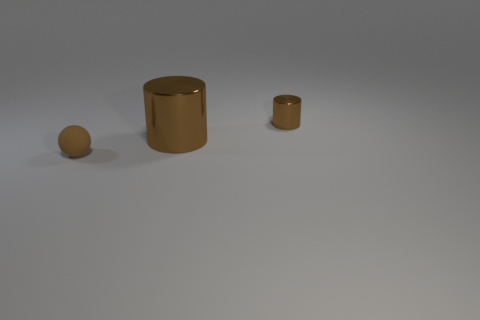Subtract 1 balls. How many balls are left? 0 Add 3 metal objects. How many objects exist? 6 Subtract all spheres. How many objects are left? 2 Subtract all metallic cylinders. Subtract all big brown metallic spheres. How many objects are left? 1 Add 1 balls. How many balls are left? 2 Add 2 spheres. How many spheres exist? 3 Subtract 0 gray balls. How many objects are left? 3 Subtract all red balls. Subtract all green cylinders. How many balls are left? 1 